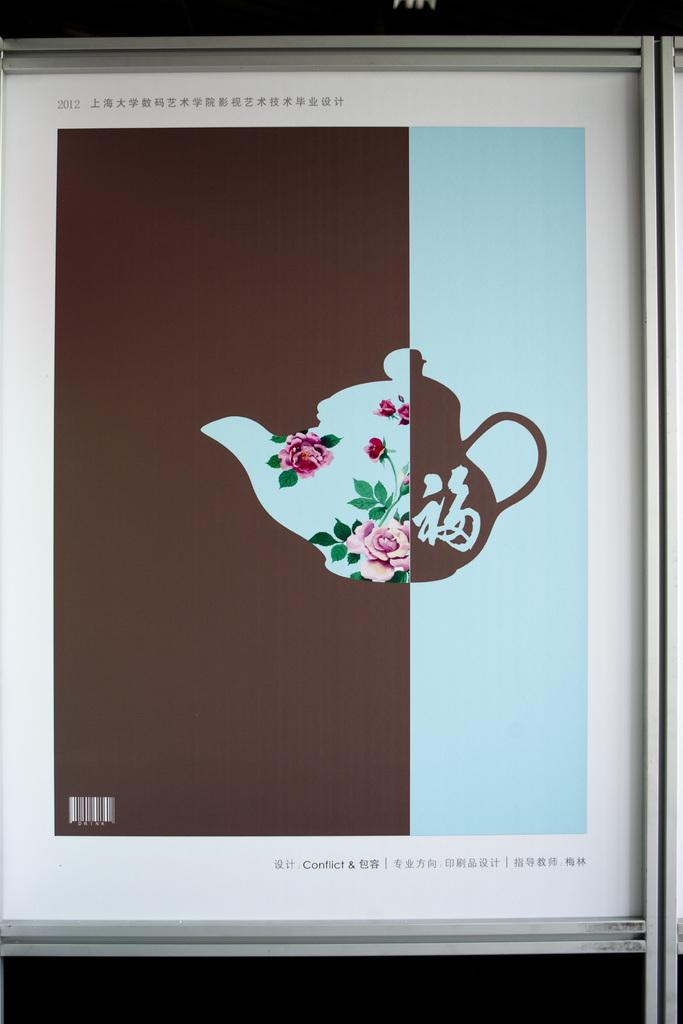<image>
Create a compact narrative representing the image presented. A framed print depicting a teapot painted in two styles and titled "Conflict & Chinese characters". 